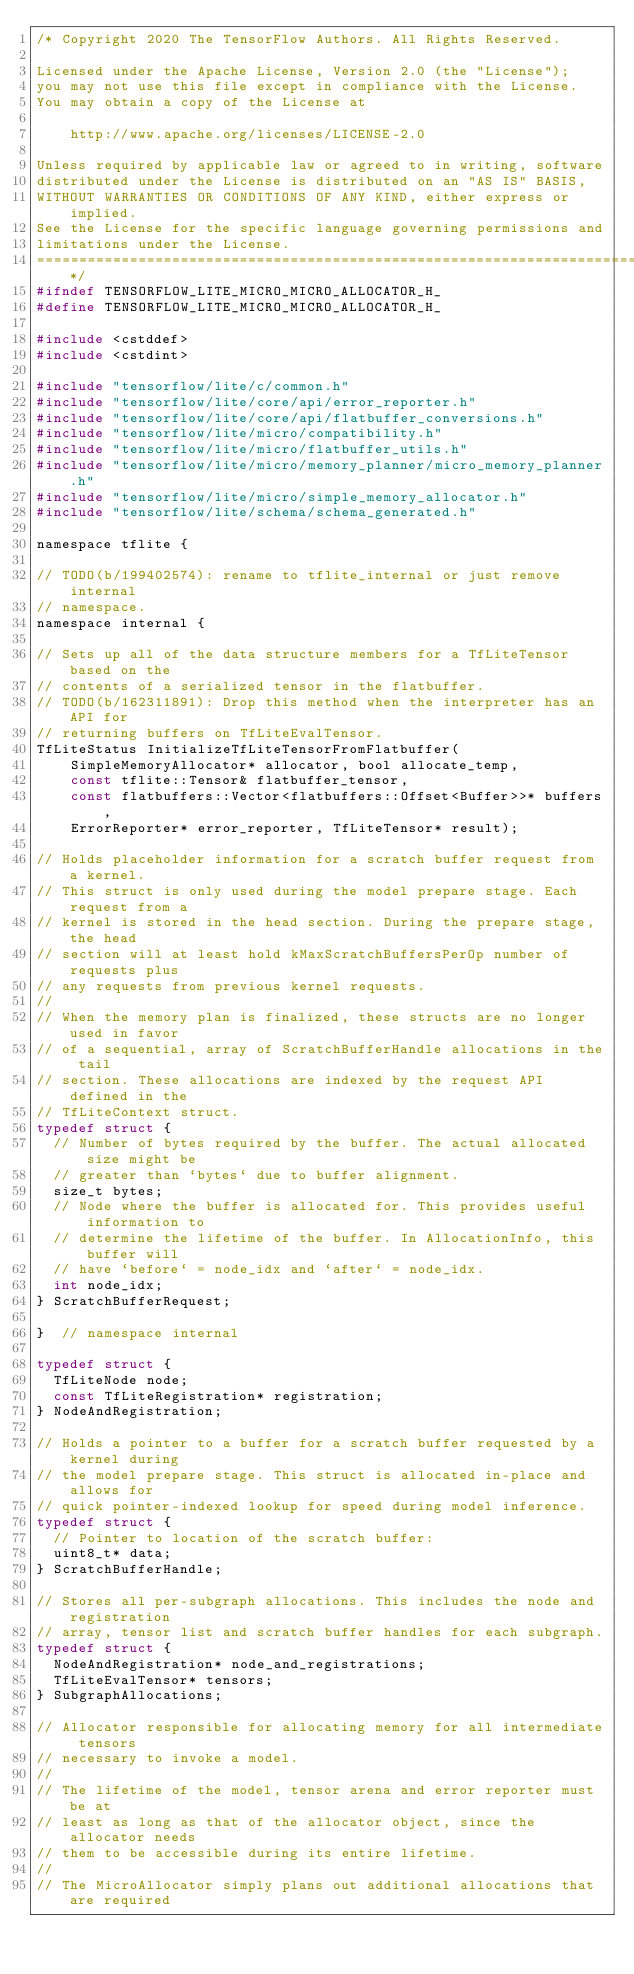Convert code to text. <code><loc_0><loc_0><loc_500><loc_500><_C_>/* Copyright 2020 The TensorFlow Authors. All Rights Reserved.

Licensed under the Apache License, Version 2.0 (the "License");
you may not use this file except in compliance with the License.
You may obtain a copy of the License at

    http://www.apache.org/licenses/LICENSE-2.0

Unless required by applicable law or agreed to in writing, software
distributed under the License is distributed on an "AS IS" BASIS,
WITHOUT WARRANTIES OR CONDITIONS OF ANY KIND, either express or implied.
See the License for the specific language governing permissions and
limitations under the License.
==============================================================================*/
#ifndef TENSORFLOW_LITE_MICRO_MICRO_ALLOCATOR_H_
#define TENSORFLOW_LITE_MICRO_MICRO_ALLOCATOR_H_

#include <cstddef>
#include <cstdint>

#include "tensorflow/lite/c/common.h"
#include "tensorflow/lite/core/api/error_reporter.h"
#include "tensorflow/lite/core/api/flatbuffer_conversions.h"
#include "tensorflow/lite/micro/compatibility.h"
#include "tensorflow/lite/micro/flatbuffer_utils.h"
#include "tensorflow/lite/micro/memory_planner/micro_memory_planner.h"
#include "tensorflow/lite/micro/simple_memory_allocator.h"
#include "tensorflow/lite/schema/schema_generated.h"

namespace tflite {

// TODO(b/199402574): rename to tflite_internal or just remove internal
// namespace.
namespace internal {

// Sets up all of the data structure members for a TfLiteTensor based on the
// contents of a serialized tensor in the flatbuffer.
// TODO(b/162311891): Drop this method when the interpreter has an API for
// returning buffers on TfLiteEvalTensor.
TfLiteStatus InitializeTfLiteTensorFromFlatbuffer(
    SimpleMemoryAllocator* allocator, bool allocate_temp,
    const tflite::Tensor& flatbuffer_tensor,
    const flatbuffers::Vector<flatbuffers::Offset<Buffer>>* buffers,
    ErrorReporter* error_reporter, TfLiteTensor* result);

// Holds placeholder information for a scratch buffer request from a kernel.
// This struct is only used during the model prepare stage. Each request from a
// kernel is stored in the head section. During the prepare stage, the head
// section will at least hold kMaxScratchBuffersPerOp number of requests plus
// any requests from previous kernel requests.
//
// When the memory plan is finalized, these structs are no longer used in favor
// of a sequential, array of ScratchBufferHandle allocations in the tail
// section. These allocations are indexed by the request API defined in the
// TfLiteContext struct.
typedef struct {
  // Number of bytes required by the buffer. The actual allocated size might be
  // greater than `bytes` due to buffer alignment.
  size_t bytes;
  // Node where the buffer is allocated for. This provides useful information to
  // determine the lifetime of the buffer. In AllocationInfo, this buffer will
  // have `before` = node_idx and `after` = node_idx.
  int node_idx;
} ScratchBufferRequest;

}  // namespace internal

typedef struct {
  TfLiteNode node;
  const TfLiteRegistration* registration;
} NodeAndRegistration;

// Holds a pointer to a buffer for a scratch buffer requested by a kernel during
// the model prepare stage. This struct is allocated in-place and allows for
// quick pointer-indexed lookup for speed during model inference.
typedef struct {
  // Pointer to location of the scratch buffer:
  uint8_t* data;
} ScratchBufferHandle;

// Stores all per-subgraph allocations. This includes the node and registration
// array, tensor list and scratch buffer handles for each subgraph.
typedef struct {
  NodeAndRegistration* node_and_registrations;
  TfLiteEvalTensor* tensors;
} SubgraphAllocations;

// Allocator responsible for allocating memory for all intermediate tensors
// necessary to invoke a model.
//
// The lifetime of the model, tensor arena and error reporter must be at
// least as long as that of the allocator object, since the allocator needs
// them to be accessible during its entire lifetime.
//
// The MicroAllocator simply plans out additional allocations that are required</code> 